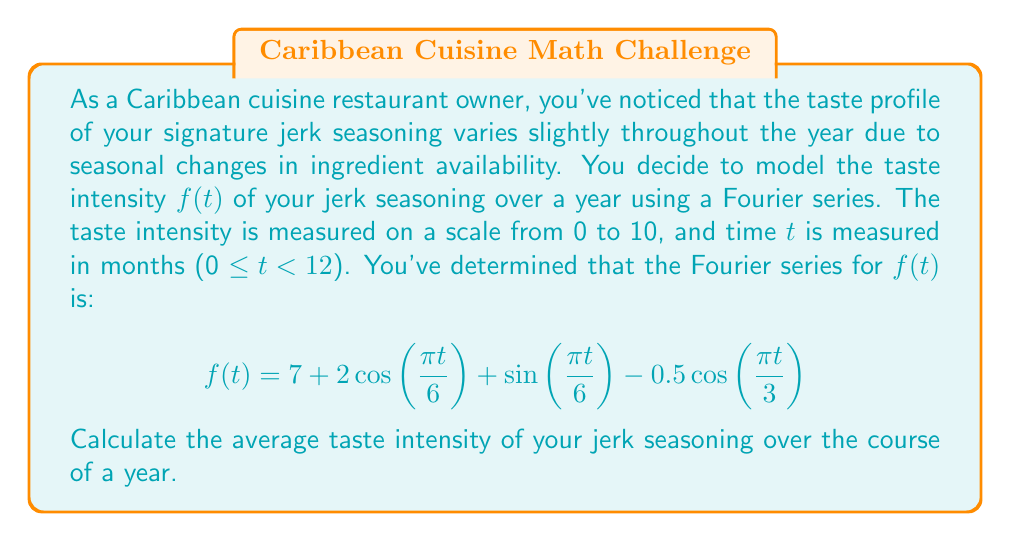What is the answer to this math problem? To find the average taste intensity over a year, we need to calculate the constant term (a₀) in the Fourier series. In a Fourier series, the constant term represents the average value of the function over its period.

Given Fourier series:
$$f(t) = 7 + 2\cos\left(\frac{\pi t}{6}\right) + \sin\left(\frac{\pi t}{6}\right) - 0.5\cos\left(\frac{\pi t}{3}\right)$$

The constant term in this series is 7. This means that regardless of the periodic fluctuations caused by the cosine and sine terms, the average value of the function over its period is 7.

To verify this mathematically:

1) The average value of any sine or cosine function over its full period is zero.
2) The period of $\cos\left(\frac{\pi t}{6}\right)$ and $\sin\left(\frac{\pi t}{6}\right)$ is 12 months (one year).
3) The period of $\cos\left(\frac{\pi t}{3}\right)$ is 6 months, so it completes two full cycles in a year.

Therefore, when we average $f(t)$ over a full year, all the trigonometric terms average to zero, leaving only the constant term 7.

Mathematically, we can express this as:

$$\text{Average} = \frac{1}{12}\int_0^{12} f(t) dt = \frac{1}{12}\int_0^{12} (7 + 2\cos\left(\frac{\pi t}{6}\right) + \sin\left(\frac{\pi t}{6}\right) - 0.5\cos\left(\frac{\pi t}{3}\right)) dt = 7$$

This result indicates that while the taste intensity of your jerk seasoning fluctuates throughout the year, its average intensity remains constant at 7 on your 0-10 scale.
Answer: The average taste intensity of the jerk seasoning over the course of a year is 7 on the 0-10 scale. 